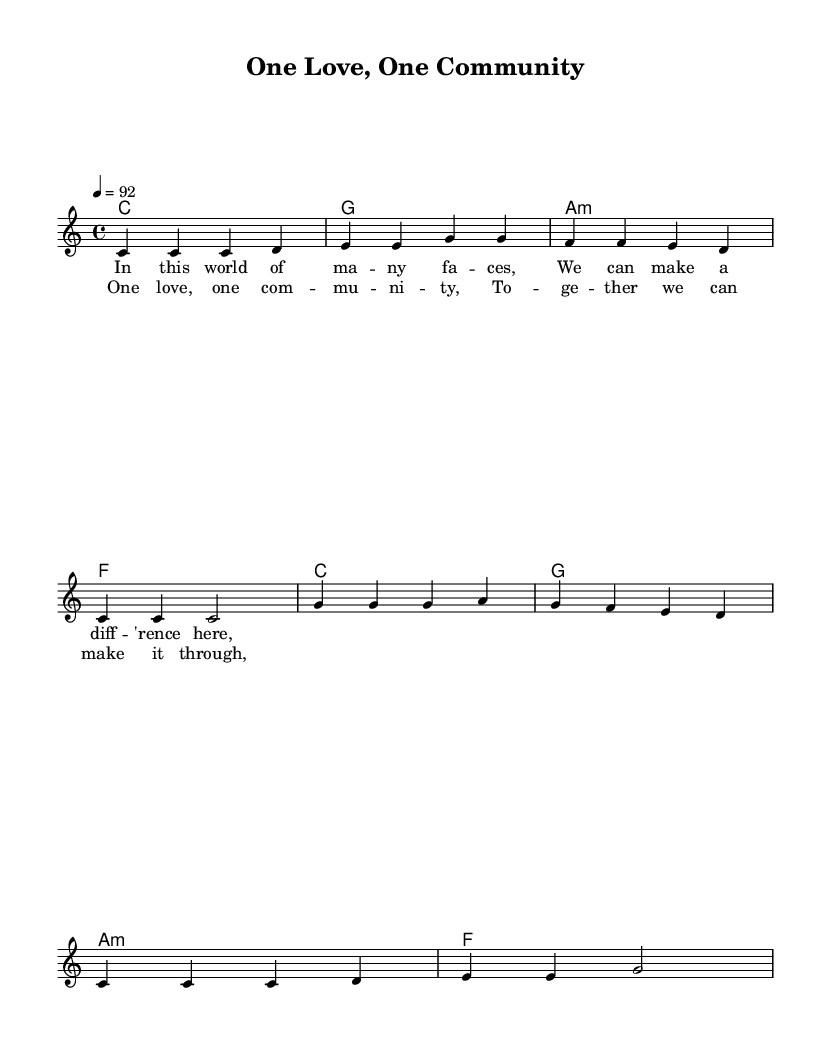What is the key signature of this music? The key signature is C major, which has no sharps or flats.
Answer: C major What is the time signature used in this composition? The time signature is indicated as 4/4, meaning there are four beats in each measure and the quarter note gets one beat.
Answer: 4/4 What is the tempo marking for this piece? The tempo marking is indicated as 4 = 92, meaning the piece should be played at 92 beats per minute.
Answer: 92 How many measures are in the verse melody? By counting the distinct phrase groups, the verse melody consists of 4 measures.
Answer: 4 What is the first note of the chorus? The first note of the chorus melody as notated is G, which is the starting pitch for the chorus section.
Answer: G Which chords accompany the chorus? The chords accompanying the chorus are C, G, Am, and F, indicative of the harmonic structure used for supporting the melody.
Answer: C, G, A minor, F How does this song reflect themes of community service? This song highlights themes of unity and collective effort through its lyrics detailing togetherness and making a difference, which are common in reggae aimed at community uplifting.
Answer: One love, one community 